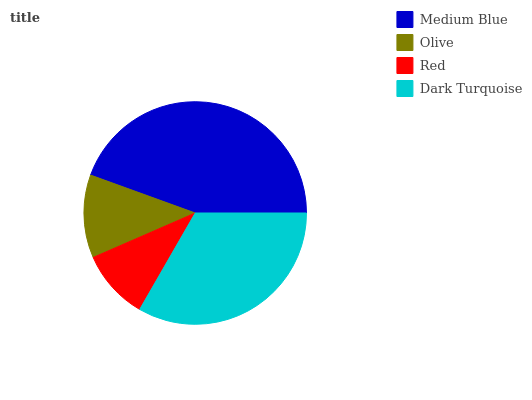Is Red the minimum?
Answer yes or no. Yes. Is Medium Blue the maximum?
Answer yes or no. Yes. Is Olive the minimum?
Answer yes or no. No. Is Olive the maximum?
Answer yes or no. No. Is Medium Blue greater than Olive?
Answer yes or no. Yes. Is Olive less than Medium Blue?
Answer yes or no. Yes. Is Olive greater than Medium Blue?
Answer yes or no. No. Is Medium Blue less than Olive?
Answer yes or no. No. Is Dark Turquoise the high median?
Answer yes or no. Yes. Is Olive the low median?
Answer yes or no. Yes. Is Red the high median?
Answer yes or no. No. Is Medium Blue the low median?
Answer yes or no. No. 